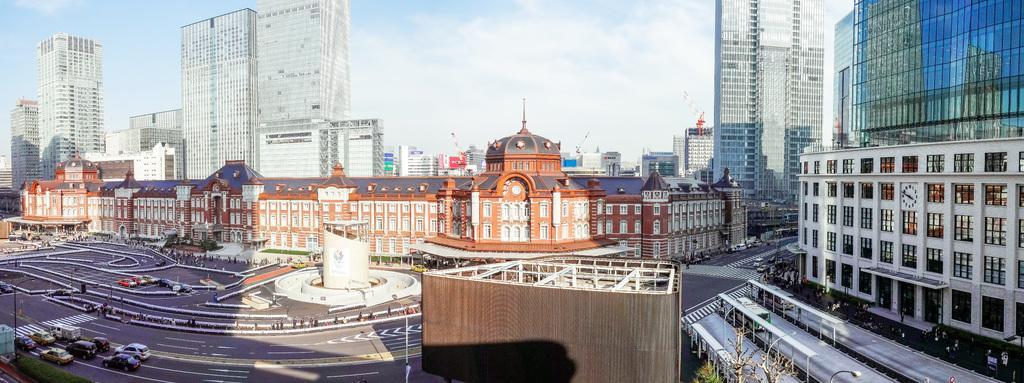Please provide a concise description of this image. In this image we can see a few buildings, there are some poles, lights, trees, vehicles on the road and some other objects, in the background we can see the sky. 